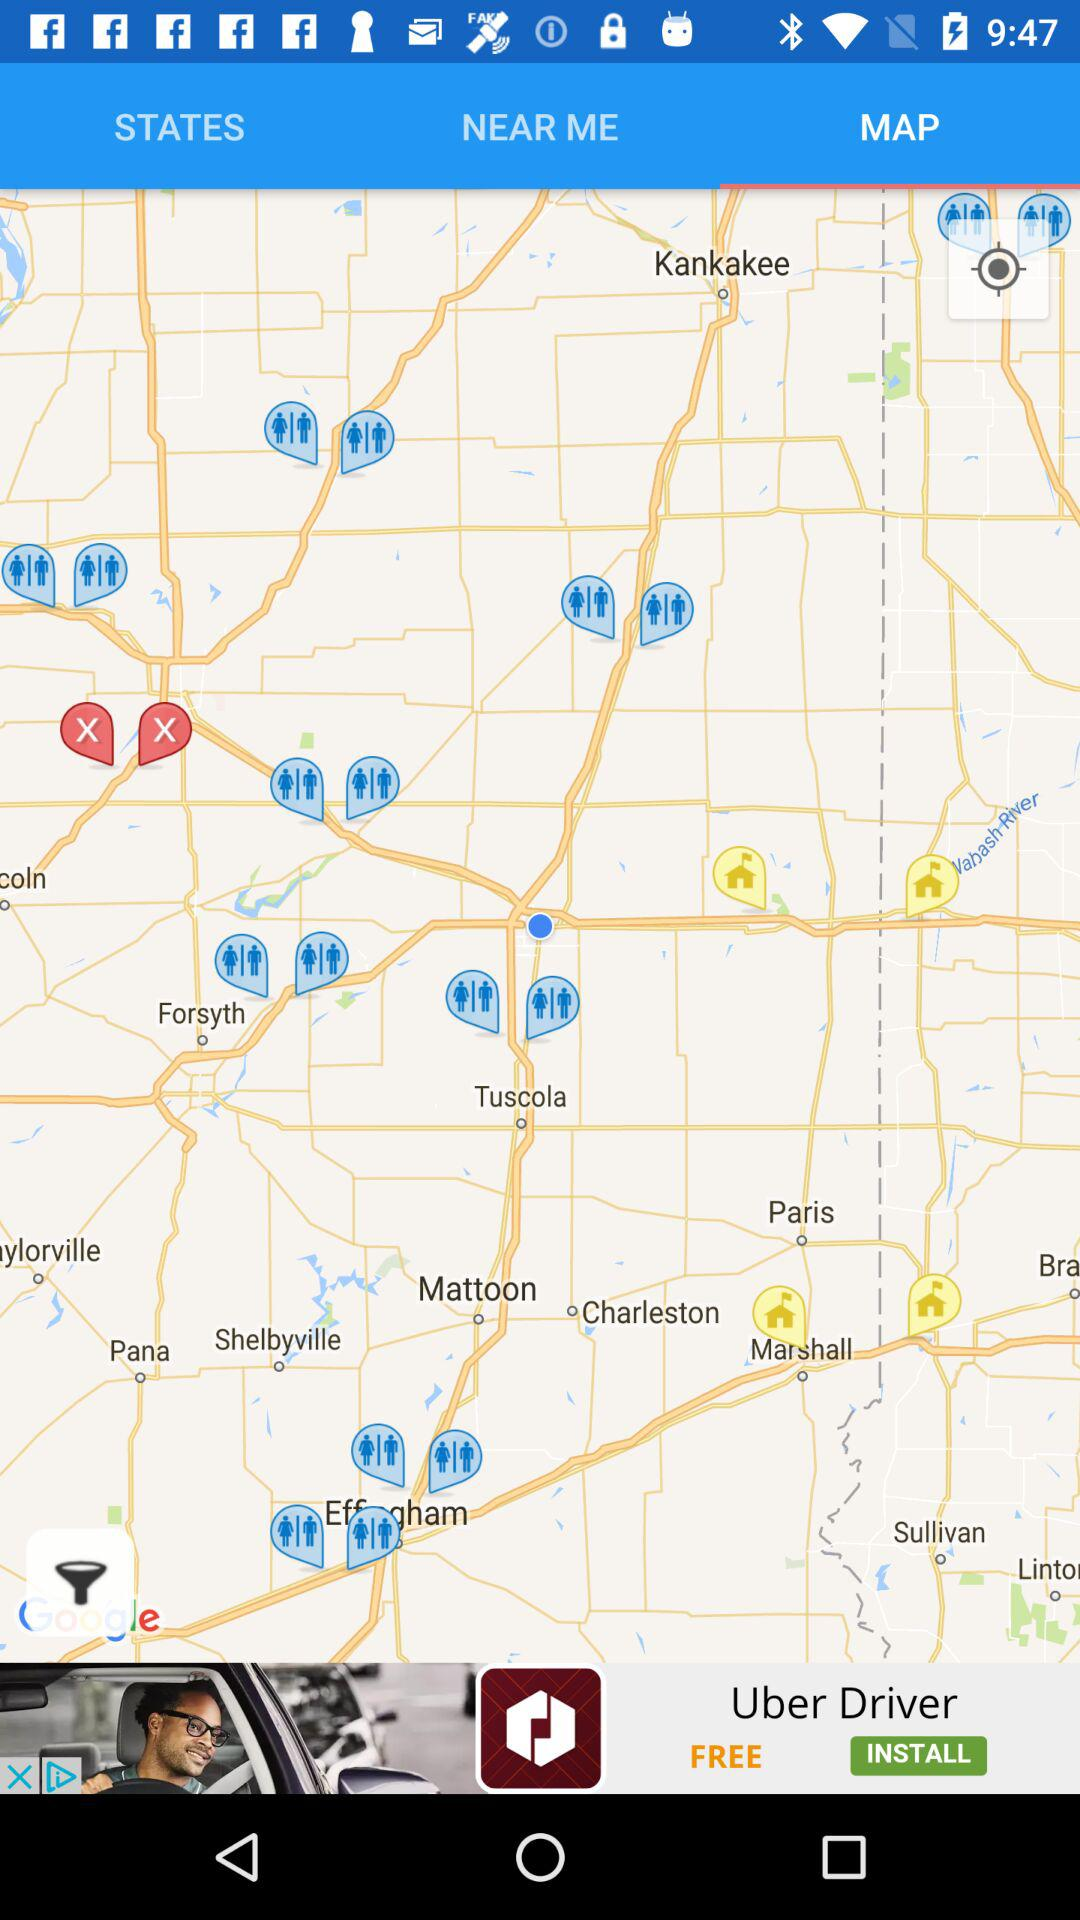Which tab is selected right now? The selected tab is "MAP". 